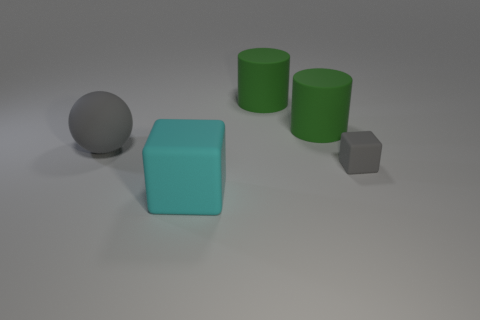What number of objects are either brown rubber balls or large spheres?
Your answer should be very brief. 1. What color is the big object in front of the gray matte ball?
Give a very brief answer. Cyan. Is the number of things left of the cyan object less than the number of blue objects?
Offer a terse response. No. There is a sphere that is the same color as the small thing; what size is it?
Ensure brevity in your answer.  Large. Are there any other things that are the same size as the gray matte sphere?
Offer a terse response. Yes. Do the gray ball and the big cyan cube have the same material?
Give a very brief answer. Yes. How many objects are either gray matte objects that are to the left of the small gray rubber object or gray objects that are to the left of the small matte object?
Give a very brief answer. 1. Are there any purple shiny spheres of the same size as the cyan rubber cube?
Give a very brief answer. No. The other thing that is the same shape as the cyan thing is what color?
Offer a very short reply. Gray. Are there any large gray rubber spheres that are behind the thing to the left of the cyan matte block?
Offer a very short reply. No. 